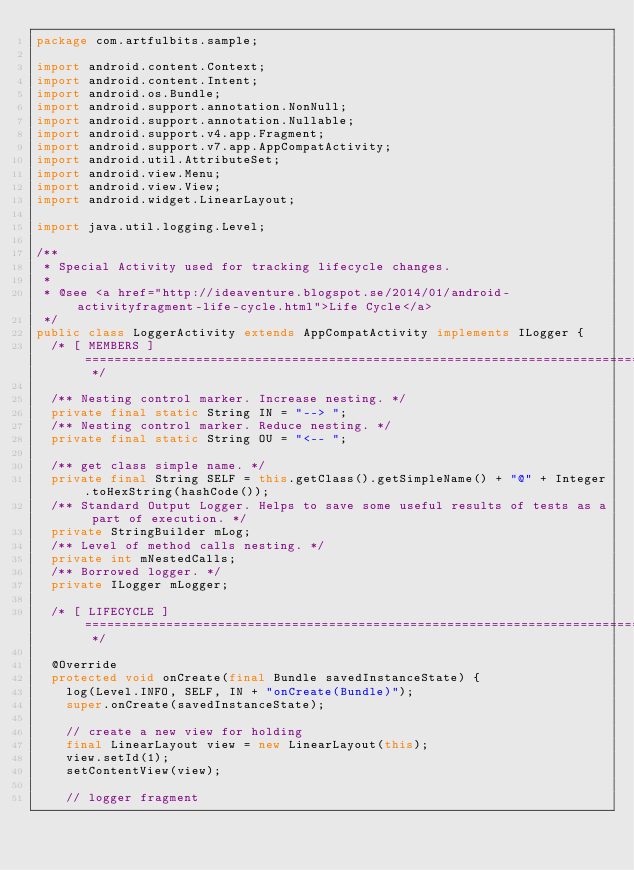Convert code to text. <code><loc_0><loc_0><loc_500><loc_500><_Java_>package com.artfulbits.sample;

import android.content.Context;
import android.content.Intent;
import android.os.Bundle;
import android.support.annotation.NonNull;
import android.support.annotation.Nullable;
import android.support.v4.app.Fragment;
import android.support.v7.app.AppCompatActivity;
import android.util.AttributeSet;
import android.view.Menu;
import android.view.View;
import android.widget.LinearLayout;

import java.util.logging.Level;

/**
 * Special Activity used for tracking lifecycle changes.
 *
 * @see <a href="http://ideaventure.blogspot.se/2014/01/android-activityfragment-life-cycle.html">Life Cycle</a>
 */
public class LoggerActivity extends AppCompatActivity implements ILogger {
  /* [ MEMBERS ] =================================================================================================== */

  /** Nesting control marker. Increase nesting. */
  private final static String IN = "--> ";
  /** Nesting control marker. Reduce nesting. */
  private final static String OU = "<-- ";

  /** get class simple name. */
  private final String SELF = this.getClass().getSimpleName() + "@" + Integer.toHexString(hashCode());
  /** Standard Output Logger. Helps to save some useful results of tests as a part of execution. */
  private StringBuilder mLog;
  /** Level of method calls nesting. */
  private int mNestedCalls;
  /** Borrowed logger. */
  private ILogger mLogger;

	/* [ LIFECYCLE ] ================================================================================================= */

  @Override
  protected void onCreate(final Bundle savedInstanceState) {
    log(Level.INFO, SELF, IN + "onCreate(Bundle)");
    super.onCreate(savedInstanceState);

    // create a new view for holding
    final LinearLayout view = new LinearLayout(this);
    view.setId(1);
    setContentView(view);

    // logger fragment</code> 